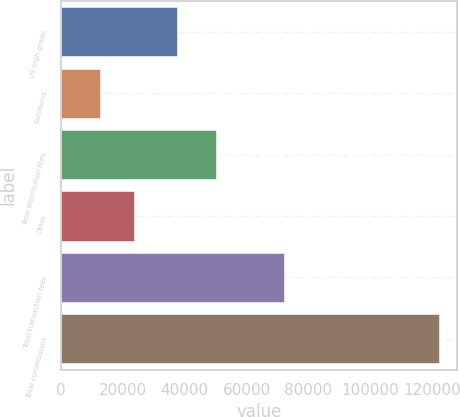Convert chart to OTSL. <chart><loc_0><loc_0><loc_500><loc_500><bar_chart><fcel>US high-grade<fcel>Eurobond<fcel>Total distribution fees<fcel>Other<fcel>Total transaction fees<fcel>Total commissions<nl><fcel>37467<fcel>12693<fcel>50160<fcel>23641.7<fcel>72020<fcel>122180<nl></chart> 